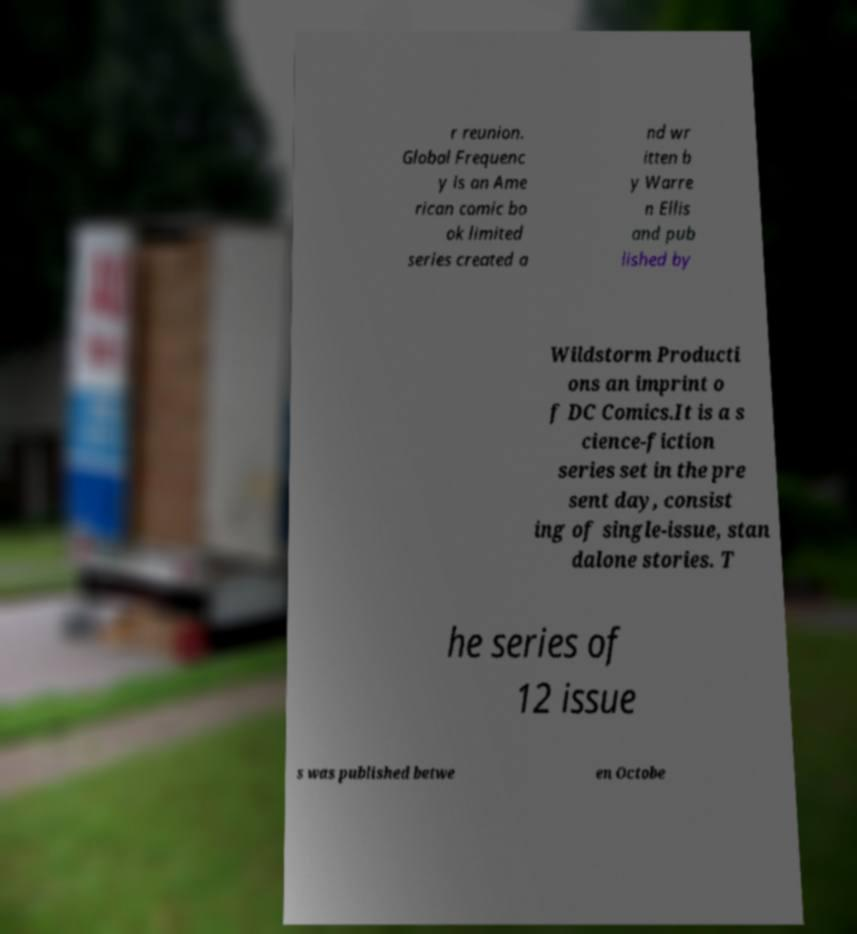Can you read and provide the text displayed in the image?This photo seems to have some interesting text. Can you extract and type it out for me? r reunion. Global Frequenc y is an Ame rican comic bo ok limited series created a nd wr itten b y Warre n Ellis and pub lished by Wildstorm Producti ons an imprint o f DC Comics.It is a s cience-fiction series set in the pre sent day, consist ing of single-issue, stan dalone stories. T he series of 12 issue s was published betwe en Octobe 